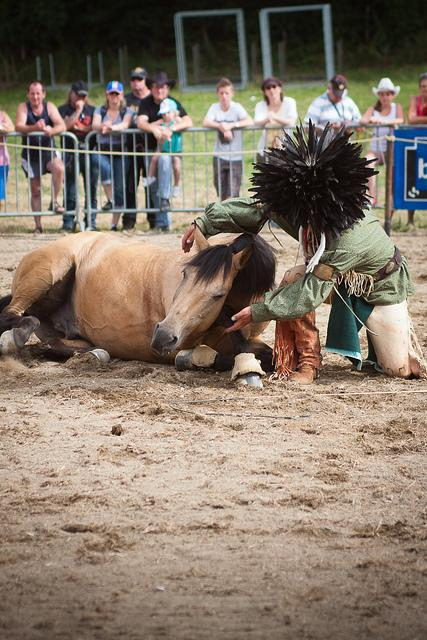Most horses that are used for racing are ridden by professional riders called as?

Choices:
A) equestrian
B) jockeys
C) riders
D) trainers jockeys 